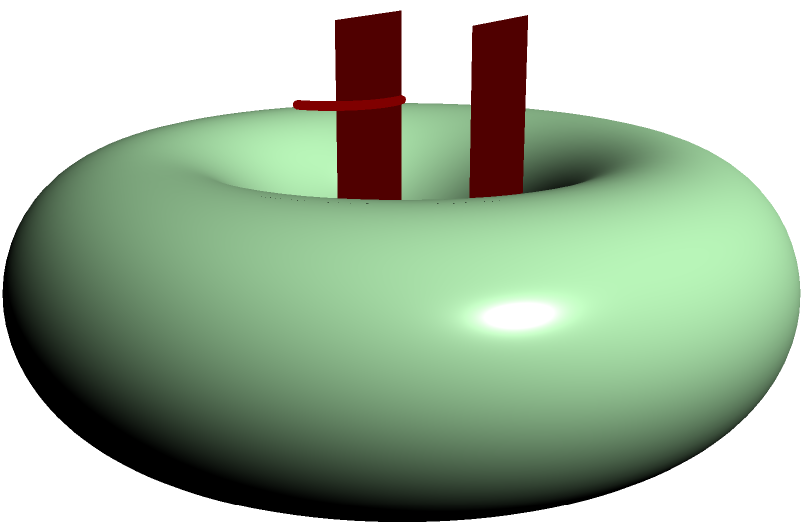As a culinary enthusiast preparing party snacks, you've created a donut-shaped cake. A friend mentions that topologically, your cake is equivalent to a coffee mug. How many "holes" does your donut-shaped cake have in topological terms, and why is this significant in relation to the coffee mug? To understand the topological equivalence between a donut-shaped cake and a coffee mug, let's break it down step-by-step:

1. In topology, we're concerned with the fundamental shape of objects, ignoring stretching, twisting, or deforming (as long as we don't create new holes or close existing ones).

2. A donut shape, mathematically known as a torus, has one distinct feature: a single hole through its center.

3. Now, let's consider a coffee mug:
   - It has a hollow interior (the main cup part)
   - It has a handle, which creates a hole

4. Topologically, the hole in the donut-shaped cake is equivalent to the hole created by the mug's handle.

5. The hollow interior of the mug can be "inflated" to form the body of the donut, while the handle remains as the hole.

6. This means that, in topological terms, both the donut-shaped cake and the coffee mug have exactly one hole.

7. The significance of this is that objects with the same number of holes are considered topologically equivalent or homeomorphic.

8. This equivalence is often used as an introductory example in topology to demonstrate that seemingly different shapes can be fundamentally the same from a topological perspective.

In culinary terms, this concept could inspire creative presentations, such as serving coffee in donut-shaped cups or creating mug-shaped cakes, playing with the topological similarity between these forms.
Answer: One hole, topologically equivalent to a coffee mug. 